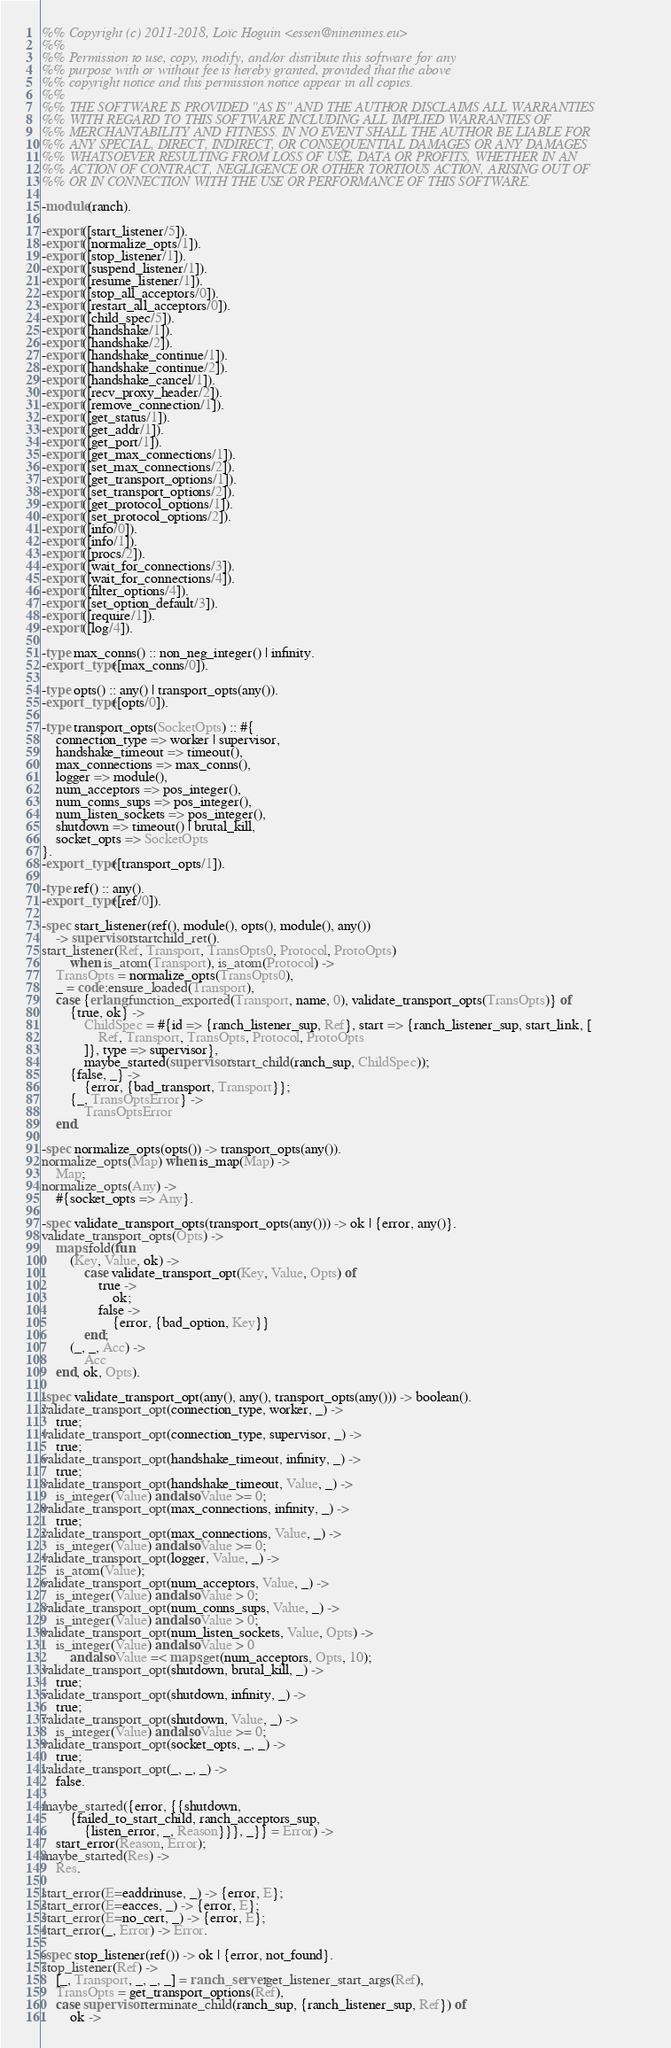<code> <loc_0><loc_0><loc_500><loc_500><_Erlang_>%% Copyright (c) 2011-2018, Loïc Hoguin <essen@ninenines.eu>
%%
%% Permission to use, copy, modify, and/or distribute this software for any
%% purpose with or without fee is hereby granted, provided that the above
%% copyright notice and this permission notice appear in all copies.
%%
%% THE SOFTWARE IS PROVIDED "AS IS" AND THE AUTHOR DISCLAIMS ALL WARRANTIES
%% WITH REGARD TO THIS SOFTWARE INCLUDING ALL IMPLIED WARRANTIES OF
%% MERCHANTABILITY AND FITNESS. IN NO EVENT SHALL THE AUTHOR BE LIABLE FOR
%% ANY SPECIAL, DIRECT, INDIRECT, OR CONSEQUENTIAL DAMAGES OR ANY DAMAGES
%% WHATSOEVER RESULTING FROM LOSS OF USE, DATA OR PROFITS, WHETHER IN AN
%% ACTION OF CONTRACT, NEGLIGENCE OR OTHER TORTIOUS ACTION, ARISING OUT OF
%% OR IN CONNECTION WITH THE USE OR PERFORMANCE OF THIS SOFTWARE.

-module(ranch).

-export([start_listener/5]).
-export([normalize_opts/1]).
-export([stop_listener/1]).
-export([suspend_listener/1]).
-export([resume_listener/1]).
-export([stop_all_acceptors/0]).
-export([restart_all_acceptors/0]).
-export([child_spec/5]).
-export([handshake/1]).
-export([handshake/2]).
-export([handshake_continue/1]).
-export([handshake_continue/2]).
-export([handshake_cancel/1]).
-export([recv_proxy_header/2]).
-export([remove_connection/1]).
-export([get_status/1]).
-export([get_addr/1]).
-export([get_port/1]).
-export([get_max_connections/1]).
-export([set_max_connections/2]).
-export([get_transport_options/1]).
-export([set_transport_options/2]).
-export([get_protocol_options/1]).
-export([set_protocol_options/2]).
-export([info/0]).
-export([info/1]).
-export([procs/2]).
-export([wait_for_connections/3]).
-export([wait_for_connections/4]).
-export([filter_options/4]).
-export([set_option_default/3]).
-export([require/1]).
-export([log/4]).

-type max_conns() :: non_neg_integer() | infinity.
-export_type([max_conns/0]).

-type opts() :: any() | transport_opts(any()).
-export_type([opts/0]).

-type transport_opts(SocketOpts) :: #{
	connection_type => worker | supervisor,
	handshake_timeout => timeout(),
	max_connections => max_conns(),
	logger => module(),
	num_acceptors => pos_integer(),
	num_conns_sups => pos_integer(),
	num_listen_sockets => pos_integer(),
	shutdown => timeout() | brutal_kill,
	socket_opts => SocketOpts
}.
-export_type([transport_opts/1]).

-type ref() :: any().
-export_type([ref/0]).

-spec start_listener(ref(), module(), opts(), module(), any())
	-> supervisor:startchild_ret().
start_listener(Ref, Transport, TransOpts0, Protocol, ProtoOpts)
		when is_atom(Transport), is_atom(Protocol) ->
	TransOpts = normalize_opts(TransOpts0),
	_ = code:ensure_loaded(Transport),
	case {erlang:function_exported(Transport, name, 0), validate_transport_opts(TransOpts)} of
		{true, ok} ->
			ChildSpec = #{id => {ranch_listener_sup, Ref}, start => {ranch_listener_sup, start_link, [
				Ref, Transport, TransOpts, Protocol, ProtoOpts
			]}, type => supervisor},
			maybe_started(supervisor:start_child(ranch_sup, ChildSpec));
		{false, _} ->
			{error, {bad_transport, Transport}};
		{_, TransOptsError} ->
			TransOptsError
	end.

-spec normalize_opts(opts()) -> transport_opts(any()).
normalize_opts(Map) when is_map(Map) ->
	Map;
normalize_opts(Any) ->
	#{socket_opts => Any}.

-spec validate_transport_opts(transport_opts(any())) -> ok | {error, any()}.
validate_transport_opts(Opts) ->
	maps:fold(fun
		(Key, Value, ok) ->
			case validate_transport_opt(Key, Value, Opts) of
				true ->
					ok;
				false ->
					{error, {bad_option, Key}}
			end;
		(_, _, Acc) ->
			Acc
	end, ok, Opts).

-spec validate_transport_opt(any(), any(), transport_opts(any())) -> boolean().
validate_transport_opt(connection_type, worker, _) ->
	true;
validate_transport_opt(connection_type, supervisor, _) ->
	true;
validate_transport_opt(handshake_timeout, infinity, _) ->
	true;
validate_transport_opt(handshake_timeout, Value, _) ->
	is_integer(Value) andalso Value >= 0;
validate_transport_opt(max_connections, infinity, _) ->
	true;
validate_transport_opt(max_connections, Value, _) ->
	is_integer(Value) andalso Value >= 0;
validate_transport_opt(logger, Value, _) ->
	is_atom(Value);
validate_transport_opt(num_acceptors, Value, _) ->
	is_integer(Value) andalso Value > 0;
validate_transport_opt(num_conns_sups, Value, _) ->
	is_integer(Value) andalso Value > 0;
validate_transport_opt(num_listen_sockets, Value, Opts) ->
	is_integer(Value) andalso Value > 0
		andalso Value =< maps:get(num_acceptors, Opts, 10);
validate_transport_opt(shutdown, brutal_kill, _) ->
	true;
validate_transport_opt(shutdown, infinity, _) ->
	true;
validate_transport_opt(shutdown, Value, _) ->
	is_integer(Value) andalso Value >= 0;
validate_transport_opt(socket_opts, _, _) ->
	true;
validate_transport_opt(_, _, _) ->
	false.

maybe_started({error, {{shutdown,
		{failed_to_start_child, ranch_acceptors_sup,
			{listen_error, _, Reason}}}, _}} = Error) ->
	start_error(Reason, Error);
maybe_started(Res) ->
	Res.

start_error(E=eaddrinuse, _) -> {error, E};
start_error(E=eacces, _) -> {error, E};
start_error(E=no_cert, _) -> {error, E};
start_error(_, Error) -> Error.

-spec stop_listener(ref()) -> ok | {error, not_found}.
stop_listener(Ref) ->
	[_, Transport, _, _, _] = ranch_server:get_listener_start_args(Ref),
	TransOpts = get_transport_options(Ref),
	case supervisor:terminate_child(ranch_sup, {ranch_listener_sup, Ref}) of
		ok -></code> 